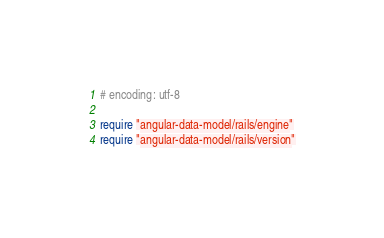<code> <loc_0><loc_0><loc_500><loc_500><_Ruby_># encoding: utf-8

require "angular-data-model/rails/engine"
require "angular-data-model/rails/version"
</code> 